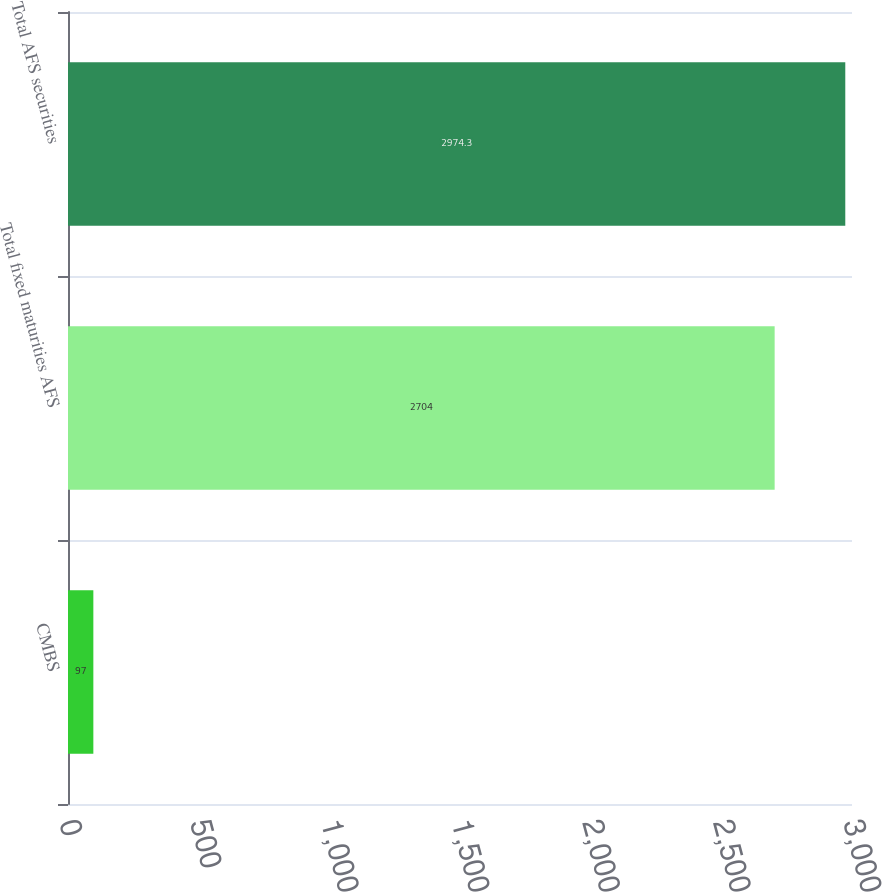Convert chart to OTSL. <chart><loc_0><loc_0><loc_500><loc_500><bar_chart><fcel>CMBS<fcel>Total fixed maturities AFS<fcel>Total AFS securities<nl><fcel>97<fcel>2704<fcel>2974.3<nl></chart> 